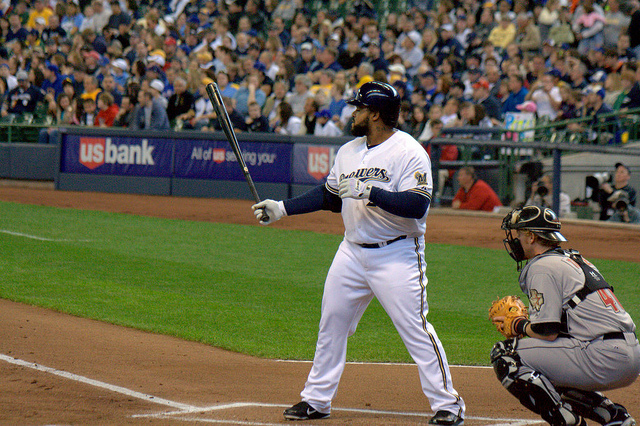<image>What number is on the baseball sign attached to the fence? I don't know what number is on the baseball sign attached to the fence. The image does not provide that information. What number is on the baseball sign attached to the fence? I don't know what number is on the baseball sign attached to the fence. It is not visible in the image. 